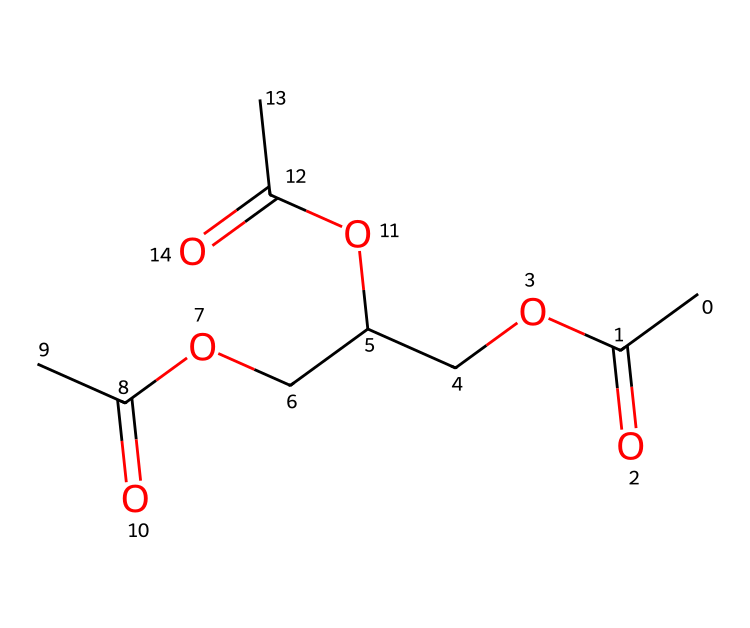What is the total number of carbon atoms in triacetin? The SMILES representation shows three acetyl (C2H3O) groups, which contributes six carbon atoms. There’s also another carbon atom in the ethylene bridge (OCC), resulting in a total of seven carbon atoms.
Answer: seven How many ester functional groups are present in triacetin? The structure includes three acetyl groups attached via ester bonds, indicating three ester functional groups. Each acetyl group contributes one ester bond.
Answer: three What is the molecular formula of triacetin? The total composition deduced from the SMILES is C9H14O5, which includes all the carbons, hydrogens, and oxygen atoms counted from the structure.
Answer: C9H14O5 What type of chemical is triacetin classified as? Triacetin is derived from the reaction of glycerol with acetic acid, making it an ester specifically formed from glycerol and three acetyls.
Answer: ester Why might triacetin be a suitable choice as a plasticizer? The presence of multiple ester groups provides flexibility and lower viscosity, making triacetin an effective plasticizer in denture adhesives that require moldable properties.
Answer: flexibility What role do the acetyl groups play in the properties of triacetin? Each acetyl group, being a carbonyl and a methyl group, contributes to the solubility and plasticizing properties due to its ability to interact with polymers.
Answer: solubility How many oxygen atoms are in triacetin? By analyzing the structure, we can see there are five oxygen atoms present: three from the ester groups and two from the bridges.
Answer: five 